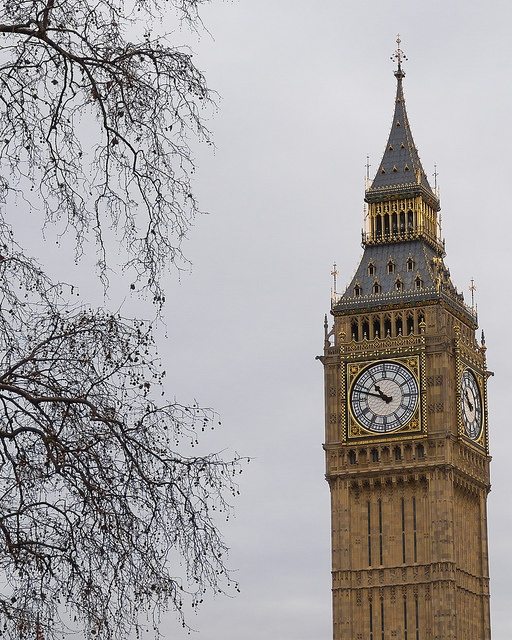Describe the objects in this image and their specific colors. I can see clock in white, darkgray, black, gray, and lightgray tones and clock in white, gray, black, darkgray, and lightgray tones in this image. 